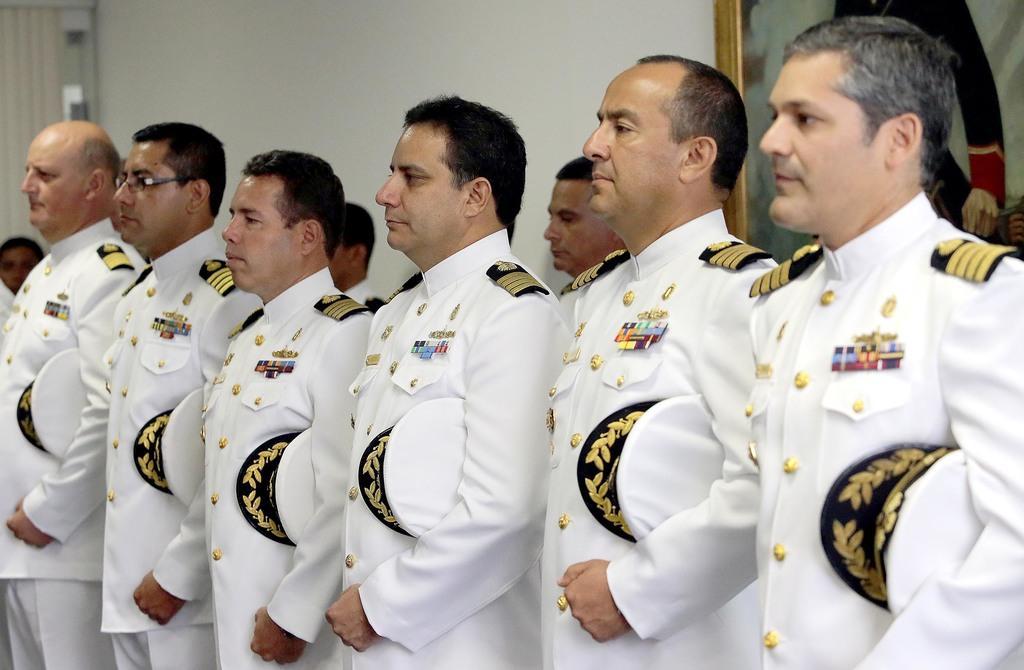Please provide a concise description of this image. In this picture we can see the officers who are wearing the white uniform and holding the cap. In the top right corner there is a painting on the wall. On the left there is a door and cloth. 